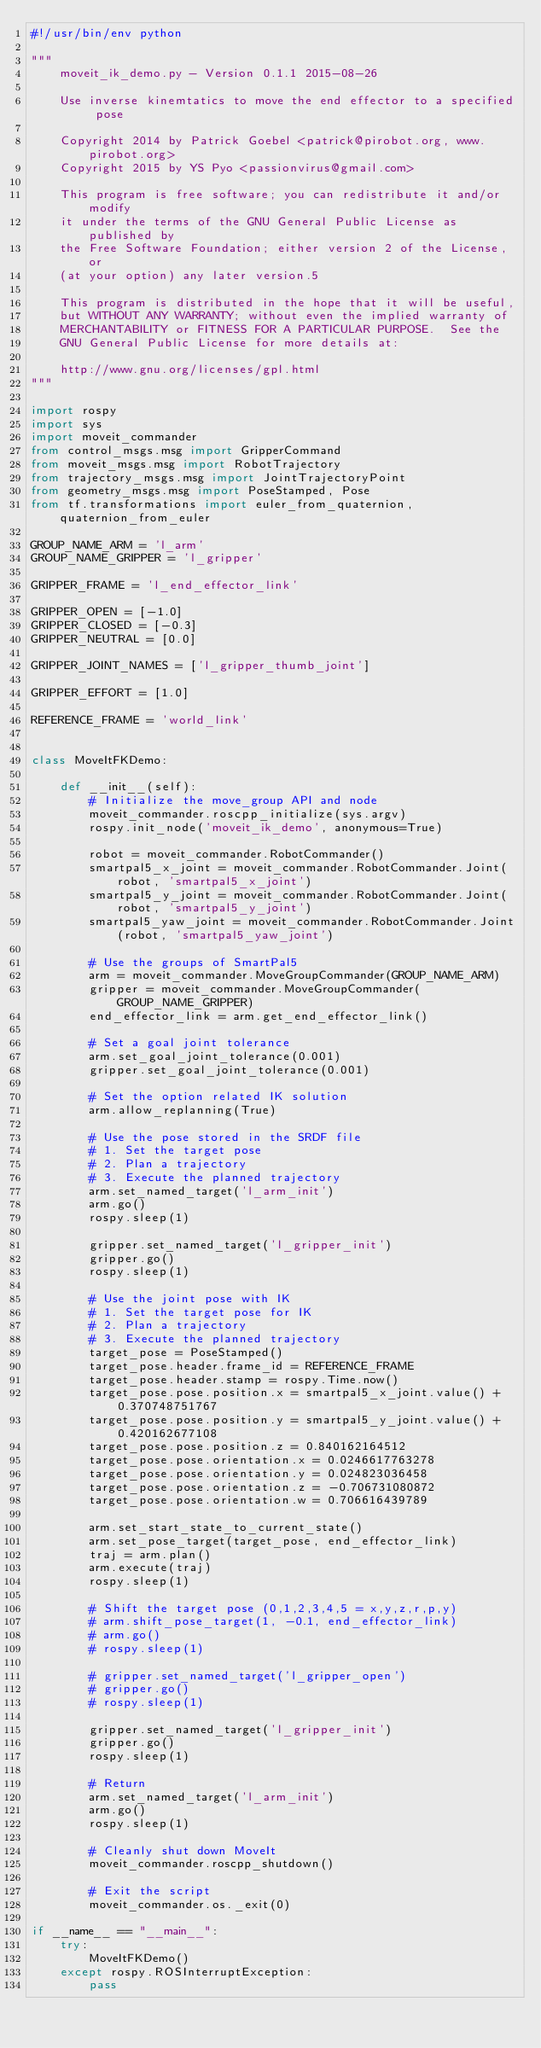<code> <loc_0><loc_0><loc_500><loc_500><_Python_>#!/usr/bin/env python

"""
    moveit_ik_demo.py - Version 0.1.1 2015-08-26

    Use inverse kinemtatics to move the end effector to a specified pose

    Copyright 2014 by Patrick Goebel <patrick@pirobot.org, www.pirobot.org>
    Copyright 2015 by YS Pyo <passionvirus@gmail.com>

    This program is free software; you can redistribute it and/or modify
    it under the terms of the GNU General Public License as published by
    the Free Software Foundation; either version 2 of the License, or
    (at your option) any later version.5

    This program is distributed in the hope that it will be useful,
    but WITHOUT ANY WARRANTY; without even the implied warranty of
    MERCHANTABILITY or FITNESS FOR A PARTICULAR PURPOSE.  See the
    GNU General Public License for more details at:

    http://www.gnu.org/licenses/gpl.html
"""

import rospy
import sys
import moveit_commander
from control_msgs.msg import GripperCommand
from moveit_msgs.msg import RobotTrajectory
from trajectory_msgs.msg import JointTrajectoryPoint
from geometry_msgs.msg import PoseStamped, Pose
from tf.transformations import euler_from_quaternion, quaternion_from_euler

GROUP_NAME_ARM = 'l_arm'
GROUP_NAME_GRIPPER = 'l_gripper'

GRIPPER_FRAME = 'l_end_effector_link'

GRIPPER_OPEN = [-1.0]
GRIPPER_CLOSED = [-0.3]
GRIPPER_NEUTRAL = [0.0]

GRIPPER_JOINT_NAMES = ['l_gripper_thumb_joint']

GRIPPER_EFFORT = [1.0]

REFERENCE_FRAME = 'world_link'


class MoveItFKDemo:

    def __init__(self):
        # Initialize the move_group API and node
        moveit_commander.roscpp_initialize(sys.argv)
        rospy.init_node('moveit_ik_demo', anonymous=True)

        robot = moveit_commander.RobotCommander()
        smartpal5_x_joint = moveit_commander.RobotCommander.Joint(robot, 'smartpal5_x_joint')
        smartpal5_y_joint = moveit_commander.RobotCommander.Joint(robot, 'smartpal5_y_joint')
        smartpal5_yaw_joint = moveit_commander.RobotCommander.Joint(robot, 'smartpal5_yaw_joint')

        # Use the groups of SmartPal5
        arm = moveit_commander.MoveGroupCommander(GROUP_NAME_ARM)
        gripper = moveit_commander.MoveGroupCommander(GROUP_NAME_GRIPPER)
        end_effector_link = arm.get_end_effector_link()

        # Set a goal joint tolerance
        arm.set_goal_joint_tolerance(0.001)
        gripper.set_goal_joint_tolerance(0.001)

        # Set the option related IK solution
        arm.allow_replanning(True)

        # Use the pose stored in the SRDF file
        # 1. Set the target pose
        # 2. Plan a trajectory
        # 3. Execute the planned trajectory
        arm.set_named_target('l_arm_init')
        arm.go()
        rospy.sleep(1)

        gripper.set_named_target('l_gripper_init')
        gripper.go()
        rospy.sleep(1)

        # Use the joint pose with IK
        # 1. Set the target pose for IK
        # 2. Plan a trajectory
        # 3. Execute the planned trajectory
        target_pose = PoseStamped()
        target_pose.header.frame_id = REFERENCE_FRAME
        target_pose.header.stamp = rospy.Time.now()
        target_pose.pose.position.x = smartpal5_x_joint.value() + 0.370748751767
        target_pose.pose.position.y = smartpal5_y_joint.value() + 0.420162677108
        target_pose.pose.position.z = 0.840162164512
        target_pose.pose.orientation.x = 0.0246617763278
        target_pose.pose.orientation.y = 0.024823036458
        target_pose.pose.orientation.z = -0.706731080872
        target_pose.pose.orientation.w = 0.706616439789

        arm.set_start_state_to_current_state()
        arm.set_pose_target(target_pose, end_effector_link)
        traj = arm.plan()
        arm.execute(traj)
        rospy.sleep(1)

        # Shift the target pose (0,1,2,3,4,5 = x,y,z,r,p,y)
        # arm.shift_pose_target(1, -0.1, end_effector_link)
        # arm.go()
        # rospy.sleep(1)

        # gripper.set_named_target('l_gripper_open')
        # gripper.go()
        # rospy.sleep(1)

        gripper.set_named_target('l_gripper_init')
        gripper.go()
        rospy.sleep(1)

        # Return
        arm.set_named_target('l_arm_init')
        arm.go()
        rospy.sleep(1)

        # Cleanly shut down MoveIt
        moveit_commander.roscpp_shutdown()

        # Exit the script
        moveit_commander.os._exit(0)

if __name__ == "__main__":
    try:
        MoveItFKDemo()
    except rospy.ROSInterruptException:
        pass
</code> 